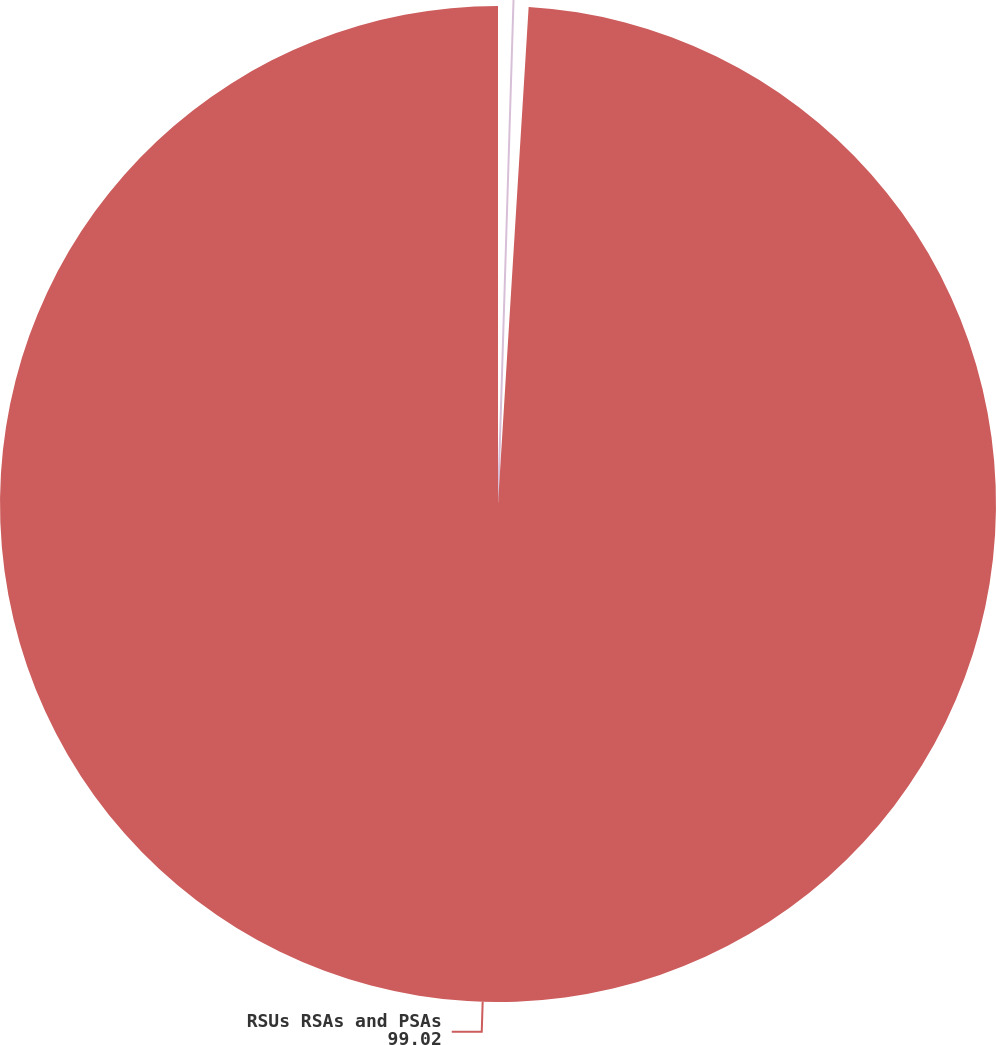Convert chart to OTSL. <chart><loc_0><loc_0><loc_500><loc_500><pie_chart><fcel>Stock options<fcel>RSUs RSAs and PSAs<nl><fcel>0.98%<fcel>99.02%<nl></chart> 